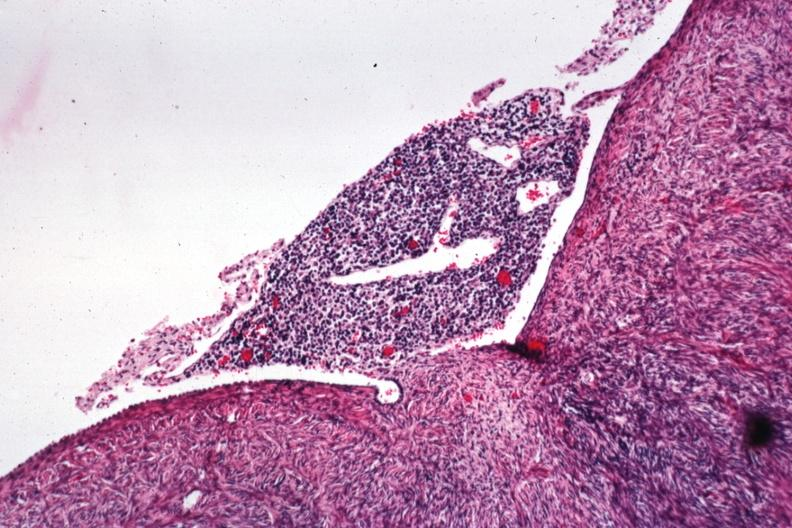what does this image show?
Answer the question using a single word or phrase. Lymphocytic infiltrate on peritoneal surface 